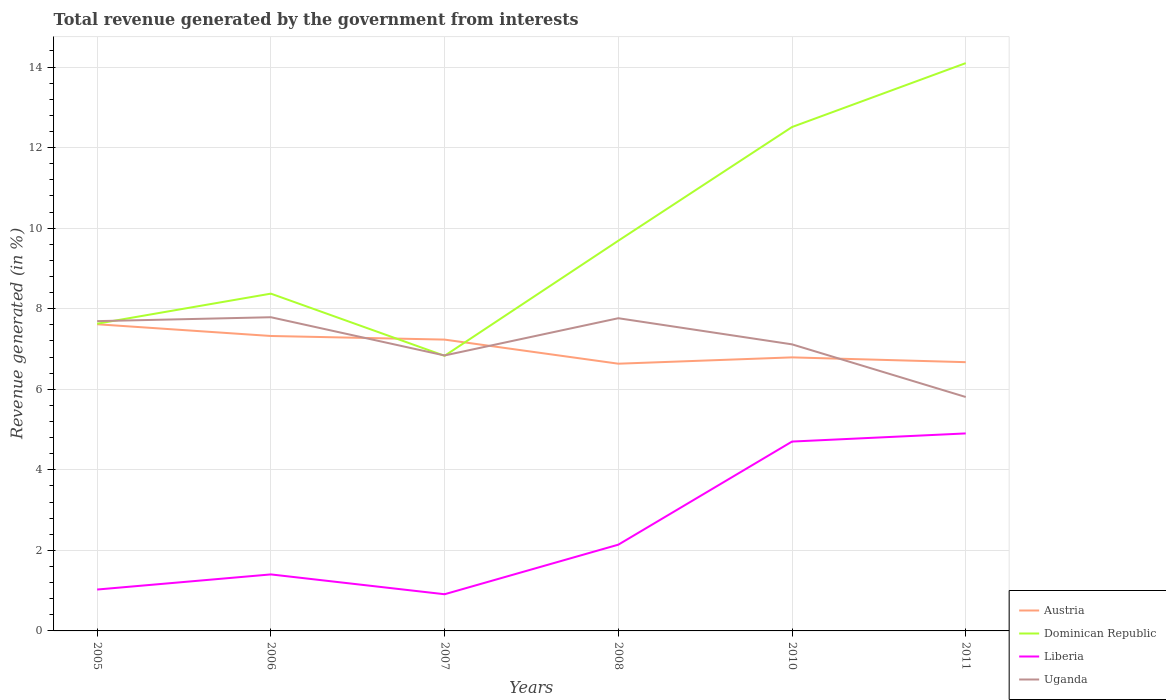How many different coloured lines are there?
Offer a very short reply. 4. Does the line corresponding to Liberia intersect with the line corresponding to Uganda?
Your answer should be compact. No. Is the number of lines equal to the number of legend labels?
Provide a short and direct response. Yes. Across all years, what is the maximum total revenue generated in Uganda?
Provide a succinct answer. 5.81. In which year was the total revenue generated in Uganda maximum?
Ensure brevity in your answer.  2011. What is the total total revenue generated in Liberia in the graph?
Your answer should be compact. -0.38. What is the difference between the highest and the second highest total revenue generated in Uganda?
Provide a short and direct response. 1.98. How many lines are there?
Keep it short and to the point. 4. Does the graph contain any zero values?
Keep it short and to the point. No. What is the title of the graph?
Provide a succinct answer. Total revenue generated by the government from interests. What is the label or title of the X-axis?
Your answer should be compact. Years. What is the label or title of the Y-axis?
Your answer should be compact. Revenue generated (in %). What is the Revenue generated (in %) of Austria in 2005?
Offer a terse response. 7.61. What is the Revenue generated (in %) in Dominican Republic in 2005?
Offer a very short reply. 7.63. What is the Revenue generated (in %) in Liberia in 2005?
Offer a terse response. 1.03. What is the Revenue generated (in %) in Uganda in 2005?
Provide a short and direct response. 7.69. What is the Revenue generated (in %) of Austria in 2006?
Provide a short and direct response. 7.32. What is the Revenue generated (in %) of Dominican Republic in 2006?
Offer a terse response. 8.37. What is the Revenue generated (in %) of Liberia in 2006?
Provide a succinct answer. 1.4. What is the Revenue generated (in %) of Uganda in 2006?
Offer a very short reply. 7.79. What is the Revenue generated (in %) of Austria in 2007?
Provide a short and direct response. 7.23. What is the Revenue generated (in %) of Dominican Republic in 2007?
Your answer should be very brief. 6.83. What is the Revenue generated (in %) of Liberia in 2007?
Offer a terse response. 0.91. What is the Revenue generated (in %) of Uganda in 2007?
Keep it short and to the point. 6.84. What is the Revenue generated (in %) in Austria in 2008?
Offer a terse response. 6.63. What is the Revenue generated (in %) in Dominican Republic in 2008?
Your answer should be compact. 9.69. What is the Revenue generated (in %) of Liberia in 2008?
Provide a short and direct response. 2.14. What is the Revenue generated (in %) of Uganda in 2008?
Keep it short and to the point. 7.76. What is the Revenue generated (in %) of Austria in 2010?
Your answer should be compact. 6.79. What is the Revenue generated (in %) in Dominican Republic in 2010?
Offer a very short reply. 12.51. What is the Revenue generated (in %) in Liberia in 2010?
Provide a short and direct response. 4.7. What is the Revenue generated (in %) of Uganda in 2010?
Keep it short and to the point. 7.11. What is the Revenue generated (in %) in Austria in 2011?
Give a very brief answer. 6.67. What is the Revenue generated (in %) of Dominican Republic in 2011?
Offer a terse response. 14.1. What is the Revenue generated (in %) in Liberia in 2011?
Provide a short and direct response. 4.9. What is the Revenue generated (in %) in Uganda in 2011?
Offer a very short reply. 5.81. Across all years, what is the maximum Revenue generated (in %) of Austria?
Keep it short and to the point. 7.61. Across all years, what is the maximum Revenue generated (in %) of Dominican Republic?
Make the answer very short. 14.1. Across all years, what is the maximum Revenue generated (in %) in Liberia?
Ensure brevity in your answer.  4.9. Across all years, what is the maximum Revenue generated (in %) in Uganda?
Keep it short and to the point. 7.79. Across all years, what is the minimum Revenue generated (in %) of Austria?
Offer a terse response. 6.63. Across all years, what is the minimum Revenue generated (in %) in Dominican Republic?
Give a very brief answer. 6.83. Across all years, what is the minimum Revenue generated (in %) of Liberia?
Provide a short and direct response. 0.91. Across all years, what is the minimum Revenue generated (in %) of Uganda?
Give a very brief answer. 5.81. What is the total Revenue generated (in %) of Austria in the graph?
Make the answer very short. 42.27. What is the total Revenue generated (in %) in Dominican Republic in the graph?
Ensure brevity in your answer.  59.13. What is the total Revenue generated (in %) in Liberia in the graph?
Keep it short and to the point. 15.09. What is the total Revenue generated (in %) of Uganda in the graph?
Offer a terse response. 43.01. What is the difference between the Revenue generated (in %) in Austria in 2005 and that in 2006?
Provide a succinct answer. 0.29. What is the difference between the Revenue generated (in %) of Dominican Republic in 2005 and that in 2006?
Ensure brevity in your answer.  -0.75. What is the difference between the Revenue generated (in %) in Liberia in 2005 and that in 2006?
Your response must be concise. -0.38. What is the difference between the Revenue generated (in %) of Uganda in 2005 and that in 2006?
Keep it short and to the point. -0.1. What is the difference between the Revenue generated (in %) of Austria in 2005 and that in 2007?
Provide a succinct answer. 0.38. What is the difference between the Revenue generated (in %) in Dominican Republic in 2005 and that in 2007?
Offer a terse response. 0.8. What is the difference between the Revenue generated (in %) of Liberia in 2005 and that in 2007?
Offer a terse response. 0.12. What is the difference between the Revenue generated (in %) in Uganda in 2005 and that in 2007?
Offer a very short reply. 0.85. What is the difference between the Revenue generated (in %) in Austria in 2005 and that in 2008?
Keep it short and to the point. 0.98. What is the difference between the Revenue generated (in %) of Dominican Republic in 2005 and that in 2008?
Make the answer very short. -2.06. What is the difference between the Revenue generated (in %) of Liberia in 2005 and that in 2008?
Give a very brief answer. -1.11. What is the difference between the Revenue generated (in %) in Uganda in 2005 and that in 2008?
Your answer should be very brief. -0.07. What is the difference between the Revenue generated (in %) of Austria in 2005 and that in 2010?
Make the answer very short. 0.82. What is the difference between the Revenue generated (in %) of Dominican Republic in 2005 and that in 2010?
Give a very brief answer. -4.88. What is the difference between the Revenue generated (in %) of Liberia in 2005 and that in 2010?
Your answer should be compact. -3.67. What is the difference between the Revenue generated (in %) of Uganda in 2005 and that in 2010?
Your answer should be compact. 0.58. What is the difference between the Revenue generated (in %) of Austria in 2005 and that in 2011?
Your answer should be compact. 0.94. What is the difference between the Revenue generated (in %) in Dominican Republic in 2005 and that in 2011?
Provide a short and direct response. -6.47. What is the difference between the Revenue generated (in %) in Liberia in 2005 and that in 2011?
Provide a succinct answer. -3.88. What is the difference between the Revenue generated (in %) of Uganda in 2005 and that in 2011?
Keep it short and to the point. 1.88. What is the difference between the Revenue generated (in %) in Austria in 2006 and that in 2007?
Offer a terse response. 0.09. What is the difference between the Revenue generated (in %) in Dominican Republic in 2006 and that in 2007?
Your answer should be very brief. 1.54. What is the difference between the Revenue generated (in %) in Liberia in 2006 and that in 2007?
Your response must be concise. 0.49. What is the difference between the Revenue generated (in %) in Uganda in 2006 and that in 2007?
Make the answer very short. 0.95. What is the difference between the Revenue generated (in %) of Austria in 2006 and that in 2008?
Your answer should be compact. 0.69. What is the difference between the Revenue generated (in %) of Dominican Republic in 2006 and that in 2008?
Your answer should be very brief. -1.31. What is the difference between the Revenue generated (in %) in Liberia in 2006 and that in 2008?
Your response must be concise. -0.74. What is the difference between the Revenue generated (in %) of Uganda in 2006 and that in 2008?
Your answer should be compact. 0.02. What is the difference between the Revenue generated (in %) in Austria in 2006 and that in 2010?
Your answer should be very brief. 0.53. What is the difference between the Revenue generated (in %) in Dominican Republic in 2006 and that in 2010?
Your answer should be compact. -4.14. What is the difference between the Revenue generated (in %) of Liberia in 2006 and that in 2010?
Give a very brief answer. -3.3. What is the difference between the Revenue generated (in %) of Uganda in 2006 and that in 2010?
Your answer should be very brief. 0.67. What is the difference between the Revenue generated (in %) of Austria in 2006 and that in 2011?
Keep it short and to the point. 0.65. What is the difference between the Revenue generated (in %) of Dominican Republic in 2006 and that in 2011?
Make the answer very short. -5.72. What is the difference between the Revenue generated (in %) in Liberia in 2006 and that in 2011?
Provide a short and direct response. -3.5. What is the difference between the Revenue generated (in %) of Uganda in 2006 and that in 2011?
Give a very brief answer. 1.98. What is the difference between the Revenue generated (in %) of Austria in 2007 and that in 2008?
Give a very brief answer. 0.6. What is the difference between the Revenue generated (in %) of Dominican Republic in 2007 and that in 2008?
Your answer should be compact. -2.86. What is the difference between the Revenue generated (in %) of Liberia in 2007 and that in 2008?
Ensure brevity in your answer.  -1.23. What is the difference between the Revenue generated (in %) of Uganda in 2007 and that in 2008?
Give a very brief answer. -0.92. What is the difference between the Revenue generated (in %) of Austria in 2007 and that in 2010?
Make the answer very short. 0.44. What is the difference between the Revenue generated (in %) of Dominican Republic in 2007 and that in 2010?
Make the answer very short. -5.68. What is the difference between the Revenue generated (in %) of Liberia in 2007 and that in 2010?
Offer a terse response. -3.79. What is the difference between the Revenue generated (in %) of Uganda in 2007 and that in 2010?
Keep it short and to the point. -0.28. What is the difference between the Revenue generated (in %) in Austria in 2007 and that in 2011?
Your answer should be very brief. 0.56. What is the difference between the Revenue generated (in %) in Dominican Republic in 2007 and that in 2011?
Keep it short and to the point. -7.27. What is the difference between the Revenue generated (in %) in Liberia in 2007 and that in 2011?
Provide a short and direct response. -3.99. What is the difference between the Revenue generated (in %) in Uganda in 2007 and that in 2011?
Offer a terse response. 1.03. What is the difference between the Revenue generated (in %) in Austria in 2008 and that in 2010?
Keep it short and to the point. -0.16. What is the difference between the Revenue generated (in %) of Dominican Republic in 2008 and that in 2010?
Make the answer very short. -2.82. What is the difference between the Revenue generated (in %) of Liberia in 2008 and that in 2010?
Provide a short and direct response. -2.56. What is the difference between the Revenue generated (in %) in Uganda in 2008 and that in 2010?
Offer a terse response. 0.65. What is the difference between the Revenue generated (in %) of Austria in 2008 and that in 2011?
Make the answer very short. -0.04. What is the difference between the Revenue generated (in %) in Dominican Republic in 2008 and that in 2011?
Your answer should be compact. -4.41. What is the difference between the Revenue generated (in %) of Liberia in 2008 and that in 2011?
Give a very brief answer. -2.76. What is the difference between the Revenue generated (in %) in Uganda in 2008 and that in 2011?
Your answer should be compact. 1.96. What is the difference between the Revenue generated (in %) of Austria in 2010 and that in 2011?
Provide a short and direct response. 0.12. What is the difference between the Revenue generated (in %) in Dominican Republic in 2010 and that in 2011?
Your answer should be very brief. -1.59. What is the difference between the Revenue generated (in %) of Liberia in 2010 and that in 2011?
Give a very brief answer. -0.2. What is the difference between the Revenue generated (in %) in Uganda in 2010 and that in 2011?
Your answer should be very brief. 1.31. What is the difference between the Revenue generated (in %) in Austria in 2005 and the Revenue generated (in %) in Dominican Republic in 2006?
Provide a short and direct response. -0.76. What is the difference between the Revenue generated (in %) in Austria in 2005 and the Revenue generated (in %) in Liberia in 2006?
Your answer should be compact. 6.21. What is the difference between the Revenue generated (in %) in Austria in 2005 and the Revenue generated (in %) in Uganda in 2006?
Give a very brief answer. -0.17. What is the difference between the Revenue generated (in %) of Dominican Republic in 2005 and the Revenue generated (in %) of Liberia in 2006?
Make the answer very short. 6.22. What is the difference between the Revenue generated (in %) of Dominican Republic in 2005 and the Revenue generated (in %) of Uganda in 2006?
Give a very brief answer. -0.16. What is the difference between the Revenue generated (in %) in Liberia in 2005 and the Revenue generated (in %) in Uganda in 2006?
Give a very brief answer. -6.76. What is the difference between the Revenue generated (in %) of Austria in 2005 and the Revenue generated (in %) of Dominican Republic in 2007?
Make the answer very short. 0.78. What is the difference between the Revenue generated (in %) in Austria in 2005 and the Revenue generated (in %) in Liberia in 2007?
Your response must be concise. 6.7. What is the difference between the Revenue generated (in %) of Austria in 2005 and the Revenue generated (in %) of Uganda in 2007?
Provide a succinct answer. 0.77. What is the difference between the Revenue generated (in %) in Dominican Republic in 2005 and the Revenue generated (in %) in Liberia in 2007?
Offer a terse response. 6.72. What is the difference between the Revenue generated (in %) of Dominican Republic in 2005 and the Revenue generated (in %) of Uganda in 2007?
Provide a short and direct response. 0.79. What is the difference between the Revenue generated (in %) of Liberia in 2005 and the Revenue generated (in %) of Uganda in 2007?
Offer a terse response. -5.81. What is the difference between the Revenue generated (in %) in Austria in 2005 and the Revenue generated (in %) in Dominican Republic in 2008?
Your answer should be compact. -2.07. What is the difference between the Revenue generated (in %) of Austria in 2005 and the Revenue generated (in %) of Liberia in 2008?
Your answer should be compact. 5.47. What is the difference between the Revenue generated (in %) of Austria in 2005 and the Revenue generated (in %) of Uganda in 2008?
Provide a short and direct response. -0.15. What is the difference between the Revenue generated (in %) in Dominican Republic in 2005 and the Revenue generated (in %) in Liberia in 2008?
Offer a terse response. 5.49. What is the difference between the Revenue generated (in %) of Dominican Republic in 2005 and the Revenue generated (in %) of Uganda in 2008?
Give a very brief answer. -0.14. What is the difference between the Revenue generated (in %) in Liberia in 2005 and the Revenue generated (in %) in Uganda in 2008?
Keep it short and to the point. -6.74. What is the difference between the Revenue generated (in %) of Austria in 2005 and the Revenue generated (in %) of Dominican Republic in 2010?
Keep it short and to the point. -4.9. What is the difference between the Revenue generated (in %) of Austria in 2005 and the Revenue generated (in %) of Liberia in 2010?
Keep it short and to the point. 2.91. What is the difference between the Revenue generated (in %) in Austria in 2005 and the Revenue generated (in %) in Uganda in 2010?
Offer a terse response. 0.5. What is the difference between the Revenue generated (in %) of Dominican Republic in 2005 and the Revenue generated (in %) of Liberia in 2010?
Offer a very short reply. 2.93. What is the difference between the Revenue generated (in %) of Dominican Republic in 2005 and the Revenue generated (in %) of Uganda in 2010?
Make the answer very short. 0.51. What is the difference between the Revenue generated (in %) of Liberia in 2005 and the Revenue generated (in %) of Uganda in 2010?
Offer a very short reply. -6.09. What is the difference between the Revenue generated (in %) in Austria in 2005 and the Revenue generated (in %) in Dominican Republic in 2011?
Make the answer very short. -6.48. What is the difference between the Revenue generated (in %) of Austria in 2005 and the Revenue generated (in %) of Liberia in 2011?
Give a very brief answer. 2.71. What is the difference between the Revenue generated (in %) of Austria in 2005 and the Revenue generated (in %) of Uganda in 2011?
Provide a short and direct response. 1.81. What is the difference between the Revenue generated (in %) in Dominican Republic in 2005 and the Revenue generated (in %) in Liberia in 2011?
Provide a succinct answer. 2.72. What is the difference between the Revenue generated (in %) of Dominican Republic in 2005 and the Revenue generated (in %) of Uganda in 2011?
Your response must be concise. 1.82. What is the difference between the Revenue generated (in %) of Liberia in 2005 and the Revenue generated (in %) of Uganda in 2011?
Offer a terse response. -4.78. What is the difference between the Revenue generated (in %) in Austria in 2006 and the Revenue generated (in %) in Dominican Republic in 2007?
Provide a succinct answer. 0.49. What is the difference between the Revenue generated (in %) in Austria in 2006 and the Revenue generated (in %) in Liberia in 2007?
Offer a terse response. 6.41. What is the difference between the Revenue generated (in %) in Austria in 2006 and the Revenue generated (in %) in Uganda in 2007?
Offer a very short reply. 0.48. What is the difference between the Revenue generated (in %) of Dominican Republic in 2006 and the Revenue generated (in %) of Liberia in 2007?
Give a very brief answer. 7.46. What is the difference between the Revenue generated (in %) of Dominican Republic in 2006 and the Revenue generated (in %) of Uganda in 2007?
Provide a succinct answer. 1.53. What is the difference between the Revenue generated (in %) in Liberia in 2006 and the Revenue generated (in %) in Uganda in 2007?
Offer a terse response. -5.44. What is the difference between the Revenue generated (in %) in Austria in 2006 and the Revenue generated (in %) in Dominican Republic in 2008?
Your response must be concise. -2.37. What is the difference between the Revenue generated (in %) of Austria in 2006 and the Revenue generated (in %) of Liberia in 2008?
Provide a succinct answer. 5.18. What is the difference between the Revenue generated (in %) in Austria in 2006 and the Revenue generated (in %) in Uganda in 2008?
Make the answer very short. -0.44. What is the difference between the Revenue generated (in %) in Dominican Republic in 2006 and the Revenue generated (in %) in Liberia in 2008?
Your answer should be very brief. 6.23. What is the difference between the Revenue generated (in %) of Dominican Republic in 2006 and the Revenue generated (in %) of Uganda in 2008?
Give a very brief answer. 0.61. What is the difference between the Revenue generated (in %) in Liberia in 2006 and the Revenue generated (in %) in Uganda in 2008?
Offer a very short reply. -6.36. What is the difference between the Revenue generated (in %) of Austria in 2006 and the Revenue generated (in %) of Dominican Republic in 2010?
Ensure brevity in your answer.  -5.19. What is the difference between the Revenue generated (in %) of Austria in 2006 and the Revenue generated (in %) of Liberia in 2010?
Your answer should be very brief. 2.62. What is the difference between the Revenue generated (in %) of Austria in 2006 and the Revenue generated (in %) of Uganda in 2010?
Offer a terse response. 0.21. What is the difference between the Revenue generated (in %) in Dominican Republic in 2006 and the Revenue generated (in %) in Liberia in 2010?
Offer a very short reply. 3.67. What is the difference between the Revenue generated (in %) of Dominican Republic in 2006 and the Revenue generated (in %) of Uganda in 2010?
Give a very brief answer. 1.26. What is the difference between the Revenue generated (in %) in Liberia in 2006 and the Revenue generated (in %) in Uganda in 2010?
Give a very brief answer. -5.71. What is the difference between the Revenue generated (in %) of Austria in 2006 and the Revenue generated (in %) of Dominican Republic in 2011?
Give a very brief answer. -6.77. What is the difference between the Revenue generated (in %) in Austria in 2006 and the Revenue generated (in %) in Liberia in 2011?
Keep it short and to the point. 2.42. What is the difference between the Revenue generated (in %) of Austria in 2006 and the Revenue generated (in %) of Uganda in 2011?
Offer a terse response. 1.51. What is the difference between the Revenue generated (in %) of Dominican Republic in 2006 and the Revenue generated (in %) of Liberia in 2011?
Keep it short and to the point. 3.47. What is the difference between the Revenue generated (in %) of Dominican Republic in 2006 and the Revenue generated (in %) of Uganda in 2011?
Your response must be concise. 2.57. What is the difference between the Revenue generated (in %) of Liberia in 2006 and the Revenue generated (in %) of Uganda in 2011?
Your answer should be compact. -4.4. What is the difference between the Revenue generated (in %) of Austria in 2007 and the Revenue generated (in %) of Dominican Republic in 2008?
Offer a terse response. -2.45. What is the difference between the Revenue generated (in %) of Austria in 2007 and the Revenue generated (in %) of Liberia in 2008?
Your answer should be very brief. 5.09. What is the difference between the Revenue generated (in %) in Austria in 2007 and the Revenue generated (in %) in Uganda in 2008?
Offer a terse response. -0.53. What is the difference between the Revenue generated (in %) of Dominican Republic in 2007 and the Revenue generated (in %) of Liberia in 2008?
Your answer should be compact. 4.69. What is the difference between the Revenue generated (in %) of Dominican Republic in 2007 and the Revenue generated (in %) of Uganda in 2008?
Ensure brevity in your answer.  -0.93. What is the difference between the Revenue generated (in %) of Liberia in 2007 and the Revenue generated (in %) of Uganda in 2008?
Your answer should be very brief. -6.85. What is the difference between the Revenue generated (in %) of Austria in 2007 and the Revenue generated (in %) of Dominican Republic in 2010?
Give a very brief answer. -5.28. What is the difference between the Revenue generated (in %) in Austria in 2007 and the Revenue generated (in %) in Liberia in 2010?
Provide a short and direct response. 2.53. What is the difference between the Revenue generated (in %) in Austria in 2007 and the Revenue generated (in %) in Uganda in 2010?
Make the answer very short. 0.12. What is the difference between the Revenue generated (in %) of Dominican Republic in 2007 and the Revenue generated (in %) of Liberia in 2010?
Provide a succinct answer. 2.13. What is the difference between the Revenue generated (in %) in Dominican Republic in 2007 and the Revenue generated (in %) in Uganda in 2010?
Give a very brief answer. -0.28. What is the difference between the Revenue generated (in %) of Liberia in 2007 and the Revenue generated (in %) of Uganda in 2010?
Your answer should be compact. -6.2. What is the difference between the Revenue generated (in %) in Austria in 2007 and the Revenue generated (in %) in Dominican Republic in 2011?
Your answer should be very brief. -6.86. What is the difference between the Revenue generated (in %) of Austria in 2007 and the Revenue generated (in %) of Liberia in 2011?
Provide a succinct answer. 2.33. What is the difference between the Revenue generated (in %) of Austria in 2007 and the Revenue generated (in %) of Uganda in 2011?
Provide a succinct answer. 1.43. What is the difference between the Revenue generated (in %) in Dominican Republic in 2007 and the Revenue generated (in %) in Liberia in 2011?
Offer a very short reply. 1.93. What is the difference between the Revenue generated (in %) in Dominican Republic in 2007 and the Revenue generated (in %) in Uganda in 2011?
Provide a short and direct response. 1.02. What is the difference between the Revenue generated (in %) of Liberia in 2007 and the Revenue generated (in %) of Uganda in 2011?
Your answer should be very brief. -4.9. What is the difference between the Revenue generated (in %) of Austria in 2008 and the Revenue generated (in %) of Dominican Republic in 2010?
Ensure brevity in your answer.  -5.88. What is the difference between the Revenue generated (in %) in Austria in 2008 and the Revenue generated (in %) in Liberia in 2010?
Your answer should be very brief. 1.93. What is the difference between the Revenue generated (in %) of Austria in 2008 and the Revenue generated (in %) of Uganda in 2010?
Offer a very short reply. -0.48. What is the difference between the Revenue generated (in %) of Dominican Republic in 2008 and the Revenue generated (in %) of Liberia in 2010?
Your answer should be very brief. 4.99. What is the difference between the Revenue generated (in %) in Dominican Republic in 2008 and the Revenue generated (in %) in Uganda in 2010?
Your response must be concise. 2.57. What is the difference between the Revenue generated (in %) in Liberia in 2008 and the Revenue generated (in %) in Uganda in 2010?
Your response must be concise. -4.97. What is the difference between the Revenue generated (in %) in Austria in 2008 and the Revenue generated (in %) in Dominican Republic in 2011?
Make the answer very short. -7.46. What is the difference between the Revenue generated (in %) in Austria in 2008 and the Revenue generated (in %) in Liberia in 2011?
Offer a terse response. 1.73. What is the difference between the Revenue generated (in %) of Austria in 2008 and the Revenue generated (in %) of Uganda in 2011?
Keep it short and to the point. 0.83. What is the difference between the Revenue generated (in %) of Dominican Republic in 2008 and the Revenue generated (in %) of Liberia in 2011?
Keep it short and to the point. 4.78. What is the difference between the Revenue generated (in %) in Dominican Republic in 2008 and the Revenue generated (in %) in Uganda in 2011?
Provide a succinct answer. 3.88. What is the difference between the Revenue generated (in %) of Liberia in 2008 and the Revenue generated (in %) of Uganda in 2011?
Keep it short and to the point. -3.67. What is the difference between the Revenue generated (in %) of Austria in 2010 and the Revenue generated (in %) of Dominican Republic in 2011?
Provide a short and direct response. -7.31. What is the difference between the Revenue generated (in %) of Austria in 2010 and the Revenue generated (in %) of Liberia in 2011?
Provide a succinct answer. 1.89. What is the difference between the Revenue generated (in %) of Austria in 2010 and the Revenue generated (in %) of Uganda in 2011?
Ensure brevity in your answer.  0.98. What is the difference between the Revenue generated (in %) in Dominican Republic in 2010 and the Revenue generated (in %) in Liberia in 2011?
Make the answer very short. 7.61. What is the difference between the Revenue generated (in %) in Dominican Republic in 2010 and the Revenue generated (in %) in Uganda in 2011?
Give a very brief answer. 6.7. What is the difference between the Revenue generated (in %) in Liberia in 2010 and the Revenue generated (in %) in Uganda in 2011?
Make the answer very short. -1.11. What is the average Revenue generated (in %) of Austria per year?
Provide a short and direct response. 7.04. What is the average Revenue generated (in %) in Dominican Republic per year?
Ensure brevity in your answer.  9.85. What is the average Revenue generated (in %) of Liberia per year?
Your answer should be compact. 2.51. What is the average Revenue generated (in %) in Uganda per year?
Ensure brevity in your answer.  7.17. In the year 2005, what is the difference between the Revenue generated (in %) of Austria and Revenue generated (in %) of Dominican Republic?
Keep it short and to the point. -0.01. In the year 2005, what is the difference between the Revenue generated (in %) of Austria and Revenue generated (in %) of Liberia?
Provide a succinct answer. 6.59. In the year 2005, what is the difference between the Revenue generated (in %) of Austria and Revenue generated (in %) of Uganda?
Your answer should be very brief. -0.08. In the year 2005, what is the difference between the Revenue generated (in %) of Dominican Republic and Revenue generated (in %) of Liberia?
Your answer should be compact. 6.6. In the year 2005, what is the difference between the Revenue generated (in %) of Dominican Republic and Revenue generated (in %) of Uganda?
Offer a terse response. -0.06. In the year 2005, what is the difference between the Revenue generated (in %) of Liberia and Revenue generated (in %) of Uganda?
Give a very brief answer. -6.66. In the year 2006, what is the difference between the Revenue generated (in %) in Austria and Revenue generated (in %) in Dominican Republic?
Give a very brief answer. -1.05. In the year 2006, what is the difference between the Revenue generated (in %) in Austria and Revenue generated (in %) in Liberia?
Give a very brief answer. 5.92. In the year 2006, what is the difference between the Revenue generated (in %) of Austria and Revenue generated (in %) of Uganda?
Ensure brevity in your answer.  -0.47. In the year 2006, what is the difference between the Revenue generated (in %) in Dominican Republic and Revenue generated (in %) in Liberia?
Your answer should be very brief. 6.97. In the year 2006, what is the difference between the Revenue generated (in %) in Dominican Republic and Revenue generated (in %) in Uganda?
Your answer should be compact. 0.59. In the year 2006, what is the difference between the Revenue generated (in %) of Liberia and Revenue generated (in %) of Uganda?
Offer a terse response. -6.39. In the year 2007, what is the difference between the Revenue generated (in %) of Austria and Revenue generated (in %) of Dominican Republic?
Offer a terse response. 0.4. In the year 2007, what is the difference between the Revenue generated (in %) in Austria and Revenue generated (in %) in Liberia?
Provide a succinct answer. 6.32. In the year 2007, what is the difference between the Revenue generated (in %) in Austria and Revenue generated (in %) in Uganda?
Offer a terse response. 0.39. In the year 2007, what is the difference between the Revenue generated (in %) in Dominican Republic and Revenue generated (in %) in Liberia?
Offer a very short reply. 5.92. In the year 2007, what is the difference between the Revenue generated (in %) of Dominican Republic and Revenue generated (in %) of Uganda?
Give a very brief answer. -0.01. In the year 2007, what is the difference between the Revenue generated (in %) of Liberia and Revenue generated (in %) of Uganda?
Make the answer very short. -5.93. In the year 2008, what is the difference between the Revenue generated (in %) in Austria and Revenue generated (in %) in Dominican Republic?
Offer a very short reply. -3.05. In the year 2008, what is the difference between the Revenue generated (in %) in Austria and Revenue generated (in %) in Liberia?
Offer a very short reply. 4.49. In the year 2008, what is the difference between the Revenue generated (in %) in Austria and Revenue generated (in %) in Uganda?
Your response must be concise. -1.13. In the year 2008, what is the difference between the Revenue generated (in %) in Dominican Republic and Revenue generated (in %) in Liberia?
Provide a short and direct response. 7.55. In the year 2008, what is the difference between the Revenue generated (in %) in Dominican Republic and Revenue generated (in %) in Uganda?
Offer a terse response. 1.92. In the year 2008, what is the difference between the Revenue generated (in %) of Liberia and Revenue generated (in %) of Uganda?
Your answer should be very brief. -5.62. In the year 2010, what is the difference between the Revenue generated (in %) of Austria and Revenue generated (in %) of Dominican Republic?
Your response must be concise. -5.72. In the year 2010, what is the difference between the Revenue generated (in %) of Austria and Revenue generated (in %) of Liberia?
Ensure brevity in your answer.  2.09. In the year 2010, what is the difference between the Revenue generated (in %) of Austria and Revenue generated (in %) of Uganda?
Your response must be concise. -0.32. In the year 2010, what is the difference between the Revenue generated (in %) in Dominican Republic and Revenue generated (in %) in Liberia?
Ensure brevity in your answer.  7.81. In the year 2010, what is the difference between the Revenue generated (in %) in Dominican Republic and Revenue generated (in %) in Uganda?
Provide a succinct answer. 5.4. In the year 2010, what is the difference between the Revenue generated (in %) of Liberia and Revenue generated (in %) of Uganda?
Provide a succinct answer. -2.41. In the year 2011, what is the difference between the Revenue generated (in %) in Austria and Revenue generated (in %) in Dominican Republic?
Make the answer very short. -7.42. In the year 2011, what is the difference between the Revenue generated (in %) of Austria and Revenue generated (in %) of Liberia?
Your response must be concise. 1.77. In the year 2011, what is the difference between the Revenue generated (in %) in Austria and Revenue generated (in %) in Uganda?
Offer a terse response. 0.86. In the year 2011, what is the difference between the Revenue generated (in %) of Dominican Republic and Revenue generated (in %) of Liberia?
Keep it short and to the point. 9.19. In the year 2011, what is the difference between the Revenue generated (in %) of Dominican Republic and Revenue generated (in %) of Uganda?
Provide a succinct answer. 8.29. In the year 2011, what is the difference between the Revenue generated (in %) of Liberia and Revenue generated (in %) of Uganda?
Provide a succinct answer. -0.9. What is the ratio of the Revenue generated (in %) of Austria in 2005 to that in 2006?
Give a very brief answer. 1.04. What is the ratio of the Revenue generated (in %) in Dominican Republic in 2005 to that in 2006?
Your answer should be very brief. 0.91. What is the ratio of the Revenue generated (in %) of Liberia in 2005 to that in 2006?
Ensure brevity in your answer.  0.73. What is the ratio of the Revenue generated (in %) of Uganda in 2005 to that in 2006?
Keep it short and to the point. 0.99. What is the ratio of the Revenue generated (in %) in Austria in 2005 to that in 2007?
Provide a succinct answer. 1.05. What is the ratio of the Revenue generated (in %) of Dominican Republic in 2005 to that in 2007?
Your answer should be compact. 1.12. What is the ratio of the Revenue generated (in %) of Liberia in 2005 to that in 2007?
Provide a short and direct response. 1.13. What is the ratio of the Revenue generated (in %) of Uganda in 2005 to that in 2007?
Offer a terse response. 1.12. What is the ratio of the Revenue generated (in %) in Austria in 2005 to that in 2008?
Your response must be concise. 1.15. What is the ratio of the Revenue generated (in %) of Dominican Republic in 2005 to that in 2008?
Keep it short and to the point. 0.79. What is the ratio of the Revenue generated (in %) of Liberia in 2005 to that in 2008?
Your response must be concise. 0.48. What is the ratio of the Revenue generated (in %) of Uganda in 2005 to that in 2008?
Your response must be concise. 0.99. What is the ratio of the Revenue generated (in %) in Austria in 2005 to that in 2010?
Make the answer very short. 1.12. What is the ratio of the Revenue generated (in %) of Dominican Republic in 2005 to that in 2010?
Ensure brevity in your answer.  0.61. What is the ratio of the Revenue generated (in %) in Liberia in 2005 to that in 2010?
Your answer should be compact. 0.22. What is the ratio of the Revenue generated (in %) in Uganda in 2005 to that in 2010?
Provide a short and direct response. 1.08. What is the ratio of the Revenue generated (in %) of Austria in 2005 to that in 2011?
Keep it short and to the point. 1.14. What is the ratio of the Revenue generated (in %) in Dominican Republic in 2005 to that in 2011?
Ensure brevity in your answer.  0.54. What is the ratio of the Revenue generated (in %) of Liberia in 2005 to that in 2011?
Your answer should be very brief. 0.21. What is the ratio of the Revenue generated (in %) in Uganda in 2005 to that in 2011?
Ensure brevity in your answer.  1.32. What is the ratio of the Revenue generated (in %) in Austria in 2006 to that in 2007?
Ensure brevity in your answer.  1.01. What is the ratio of the Revenue generated (in %) in Dominican Republic in 2006 to that in 2007?
Give a very brief answer. 1.23. What is the ratio of the Revenue generated (in %) in Liberia in 2006 to that in 2007?
Your answer should be very brief. 1.54. What is the ratio of the Revenue generated (in %) of Uganda in 2006 to that in 2007?
Provide a short and direct response. 1.14. What is the ratio of the Revenue generated (in %) of Austria in 2006 to that in 2008?
Your response must be concise. 1.1. What is the ratio of the Revenue generated (in %) in Dominican Republic in 2006 to that in 2008?
Your answer should be very brief. 0.86. What is the ratio of the Revenue generated (in %) in Liberia in 2006 to that in 2008?
Provide a succinct answer. 0.66. What is the ratio of the Revenue generated (in %) of Uganda in 2006 to that in 2008?
Your response must be concise. 1. What is the ratio of the Revenue generated (in %) in Austria in 2006 to that in 2010?
Offer a very short reply. 1.08. What is the ratio of the Revenue generated (in %) in Dominican Republic in 2006 to that in 2010?
Provide a short and direct response. 0.67. What is the ratio of the Revenue generated (in %) in Liberia in 2006 to that in 2010?
Make the answer very short. 0.3. What is the ratio of the Revenue generated (in %) of Uganda in 2006 to that in 2010?
Provide a succinct answer. 1.09. What is the ratio of the Revenue generated (in %) of Austria in 2006 to that in 2011?
Your answer should be compact. 1.1. What is the ratio of the Revenue generated (in %) in Dominican Republic in 2006 to that in 2011?
Provide a succinct answer. 0.59. What is the ratio of the Revenue generated (in %) of Liberia in 2006 to that in 2011?
Your answer should be very brief. 0.29. What is the ratio of the Revenue generated (in %) of Uganda in 2006 to that in 2011?
Provide a short and direct response. 1.34. What is the ratio of the Revenue generated (in %) in Austria in 2007 to that in 2008?
Offer a very short reply. 1.09. What is the ratio of the Revenue generated (in %) of Dominican Republic in 2007 to that in 2008?
Make the answer very short. 0.7. What is the ratio of the Revenue generated (in %) in Liberia in 2007 to that in 2008?
Offer a very short reply. 0.43. What is the ratio of the Revenue generated (in %) in Uganda in 2007 to that in 2008?
Offer a very short reply. 0.88. What is the ratio of the Revenue generated (in %) of Austria in 2007 to that in 2010?
Give a very brief answer. 1.06. What is the ratio of the Revenue generated (in %) of Dominican Republic in 2007 to that in 2010?
Keep it short and to the point. 0.55. What is the ratio of the Revenue generated (in %) of Liberia in 2007 to that in 2010?
Your answer should be compact. 0.19. What is the ratio of the Revenue generated (in %) in Uganda in 2007 to that in 2010?
Provide a succinct answer. 0.96. What is the ratio of the Revenue generated (in %) in Austria in 2007 to that in 2011?
Ensure brevity in your answer.  1.08. What is the ratio of the Revenue generated (in %) in Dominican Republic in 2007 to that in 2011?
Provide a succinct answer. 0.48. What is the ratio of the Revenue generated (in %) in Liberia in 2007 to that in 2011?
Ensure brevity in your answer.  0.19. What is the ratio of the Revenue generated (in %) of Uganda in 2007 to that in 2011?
Offer a very short reply. 1.18. What is the ratio of the Revenue generated (in %) of Austria in 2008 to that in 2010?
Provide a succinct answer. 0.98. What is the ratio of the Revenue generated (in %) of Dominican Republic in 2008 to that in 2010?
Keep it short and to the point. 0.77. What is the ratio of the Revenue generated (in %) in Liberia in 2008 to that in 2010?
Your answer should be very brief. 0.46. What is the ratio of the Revenue generated (in %) in Uganda in 2008 to that in 2010?
Give a very brief answer. 1.09. What is the ratio of the Revenue generated (in %) of Dominican Republic in 2008 to that in 2011?
Provide a succinct answer. 0.69. What is the ratio of the Revenue generated (in %) in Liberia in 2008 to that in 2011?
Offer a very short reply. 0.44. What is the ratio of the Revenue generated (in %) in Uganda in 2008 to that in 2011?
Keep it short and to the point. 1.34. What is the ratio of the Revenue generated (in %) of Austria in 2010 to that in 2011?
Your answer should be compact. 1.02. What is the ratio of the Revenue generated (in %) in Dominican Republic in 2010 to that in 2011?
Make the answer very short. 0.89. What is the ratio of the Revenue generated (in %) of Liberia in 2010 to that in 2011?
Keep it short and to the point. 0.96. What is the ratio of the Revenue generated (in %) in Uganda in 2010 to that in 2011?
Make the answer very short. 1.23. What is the difference between the highest and the second highest Revenue generated (in %) of Austria?
Provide a short and direct response. 0.29. What is the difference between the highest and the second highest Revenue generated (in %) of Dominican Republic?
Make the answer very short. 1.59. What is the difference between the highest and the second highest Revenue generated (in %) of Liberia?
Your answer should be very brief. 0.2. What is the difference between the highest and the second highest Revenue generated (in %) in Uganda?
Give a very brief answer. 0.02. What is the difference between the highest and the lowest Revenue generated (in %) of Austria?
Offer a terse response. 0.98. What is the difference between the highest and the lowest Revenue generated (in %) in Dominican Republic?
Ensure brevity in your answer.  7.27. What is the difference between the highest and the lowest Revenue generated (in %) of Liberia?
Give a very brief answer. 3.99. What is the difference between the highest and the lowest Revenue generated (in %) in Uganda?
Make the answer very short. 1.98. 